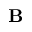Convert formula to latex. <formula><loc_0><loc_0><loc_500><loc_500>B</formula> 